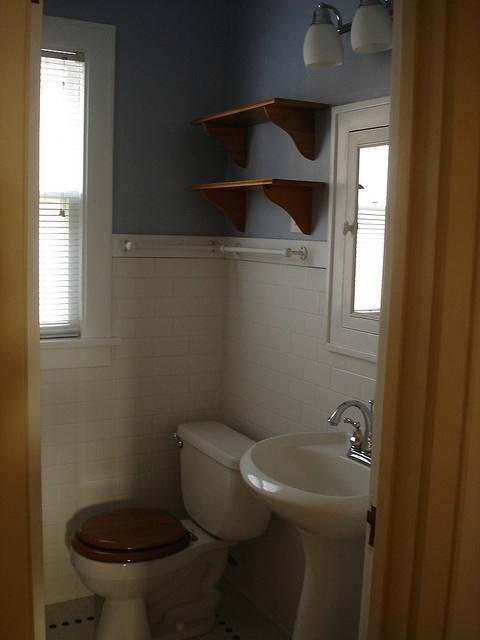Describe the objects in this image and their specific colors. I can see toilet in maroon, black, and gray tones and sink in maroon, gray, and black tones in this image. 